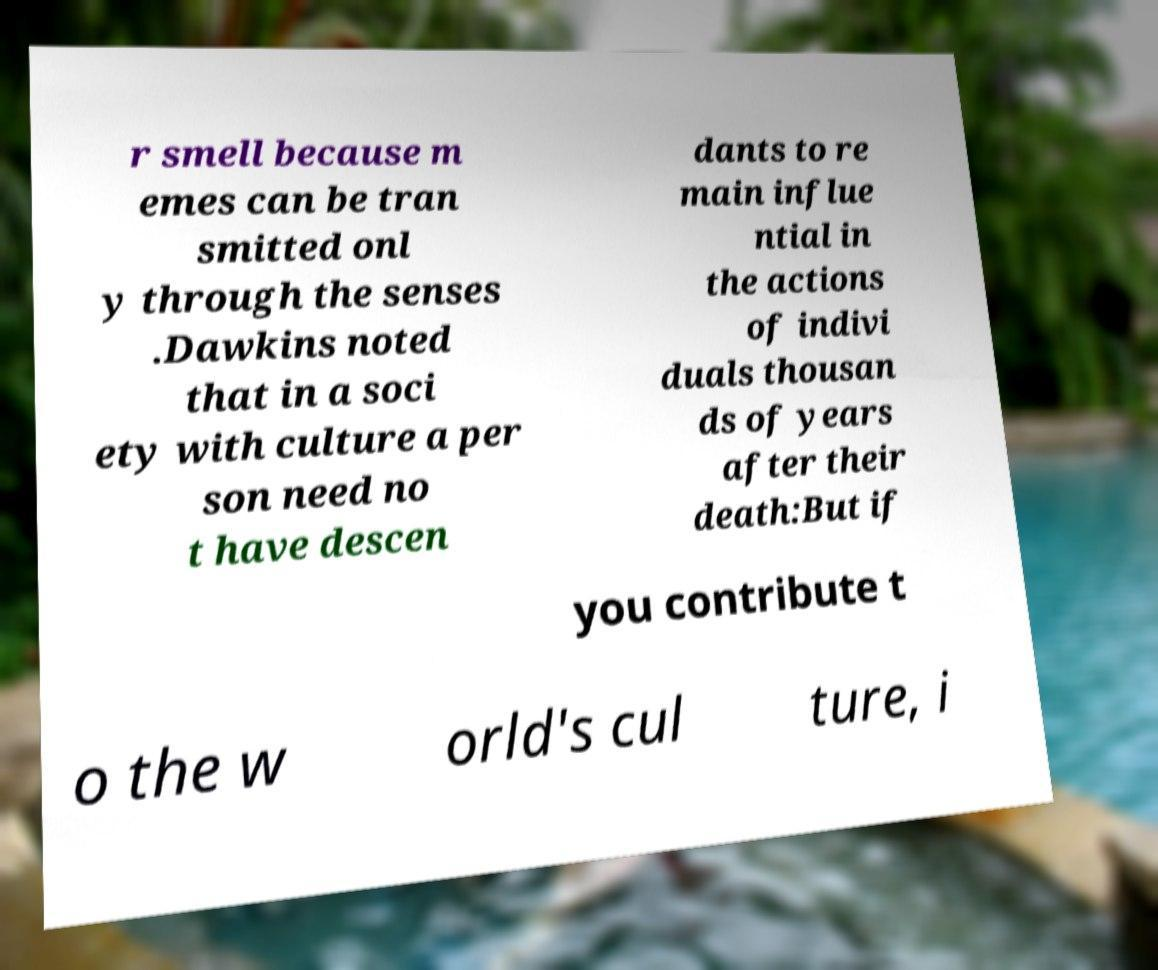Please identify and transcribe the text found in this image. r smell because m emes can be tran smitted onl y through the senses .Dawkins noted that in a soci ety with culture a per son need no t have descen dants to re main influe ntial in the actions of indivi duals thousan ds of years after their death:But if you contribute t o the w orld's cul ture, i 